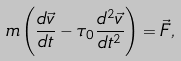<formula> <loc_0><loc_0><loc_500><loc_500>m \left ( \frac { d \vec { v } } { d t } - \tau _ { 0 } \frac { d ^ { 2 } \vec { v } } { d t ^ { 2 } } \right ) = \vec { F } ,</formula> 